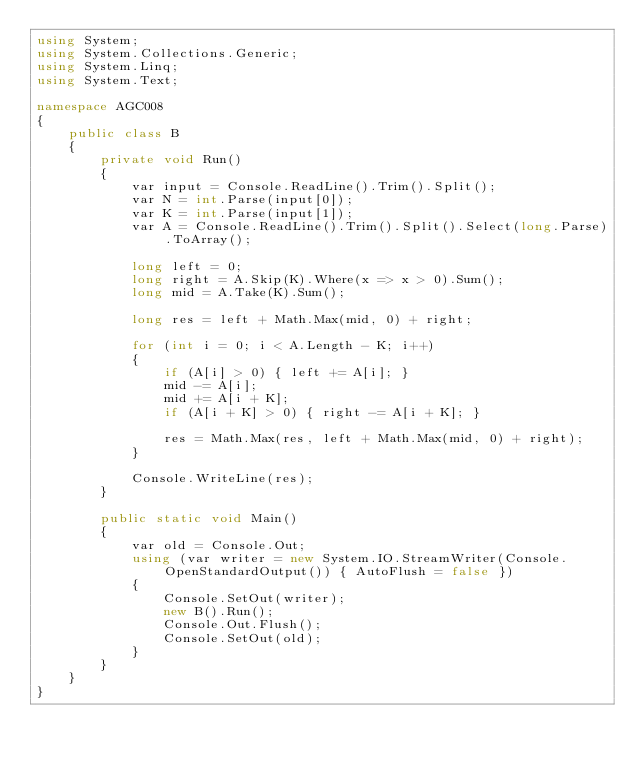<code> <loc_0><loc_0><loc_500><loc_500><_C#_>using System;
using System.Collections.Generic;
using System.Linq;
using System.Text;

namespace AGC008
{
    public class B
    {
        private void Run()
        {
            var input = Console.ReadLine().Trim().Split();
            var N = int.Parse(input[0]);
            var K = int.Parse(input[1]);
            var A = Console.ReadLine().Trim().Split().Select(long.Parse).ToArray();

            long left = 0;
            long right = A.Skip(K).Where(x => x > 0).Sum();
            long mid = A.Take(K).Sum();

            long res = left + Math.Max(mid, 0) + right;

            for (int i = 0; i < A.Length - K; i++)
            {
                if (A[i] > 0) { left += A[i]; }
                mid -= A[i];
                mid += A[i + K];
                if (A[i + K] > 0) { right -= A[i + K]; }

                res = Math.Max(res, left + Math.Max(mid, 0) + right);
            }

            Console.WriteLine(res);
        }

        public static void Main()
        {
            var old = Console.Out;
            using (var writer = new System.IO.StreamWriter(Console.OpenStandardOutput()) { AutoFlush = false })
            {
                Console.SetOut(writer);
                new B().Run();
                Console.Out.Flush();
                Console.SetOut(old);
            }
        }
    }
}
</code> 